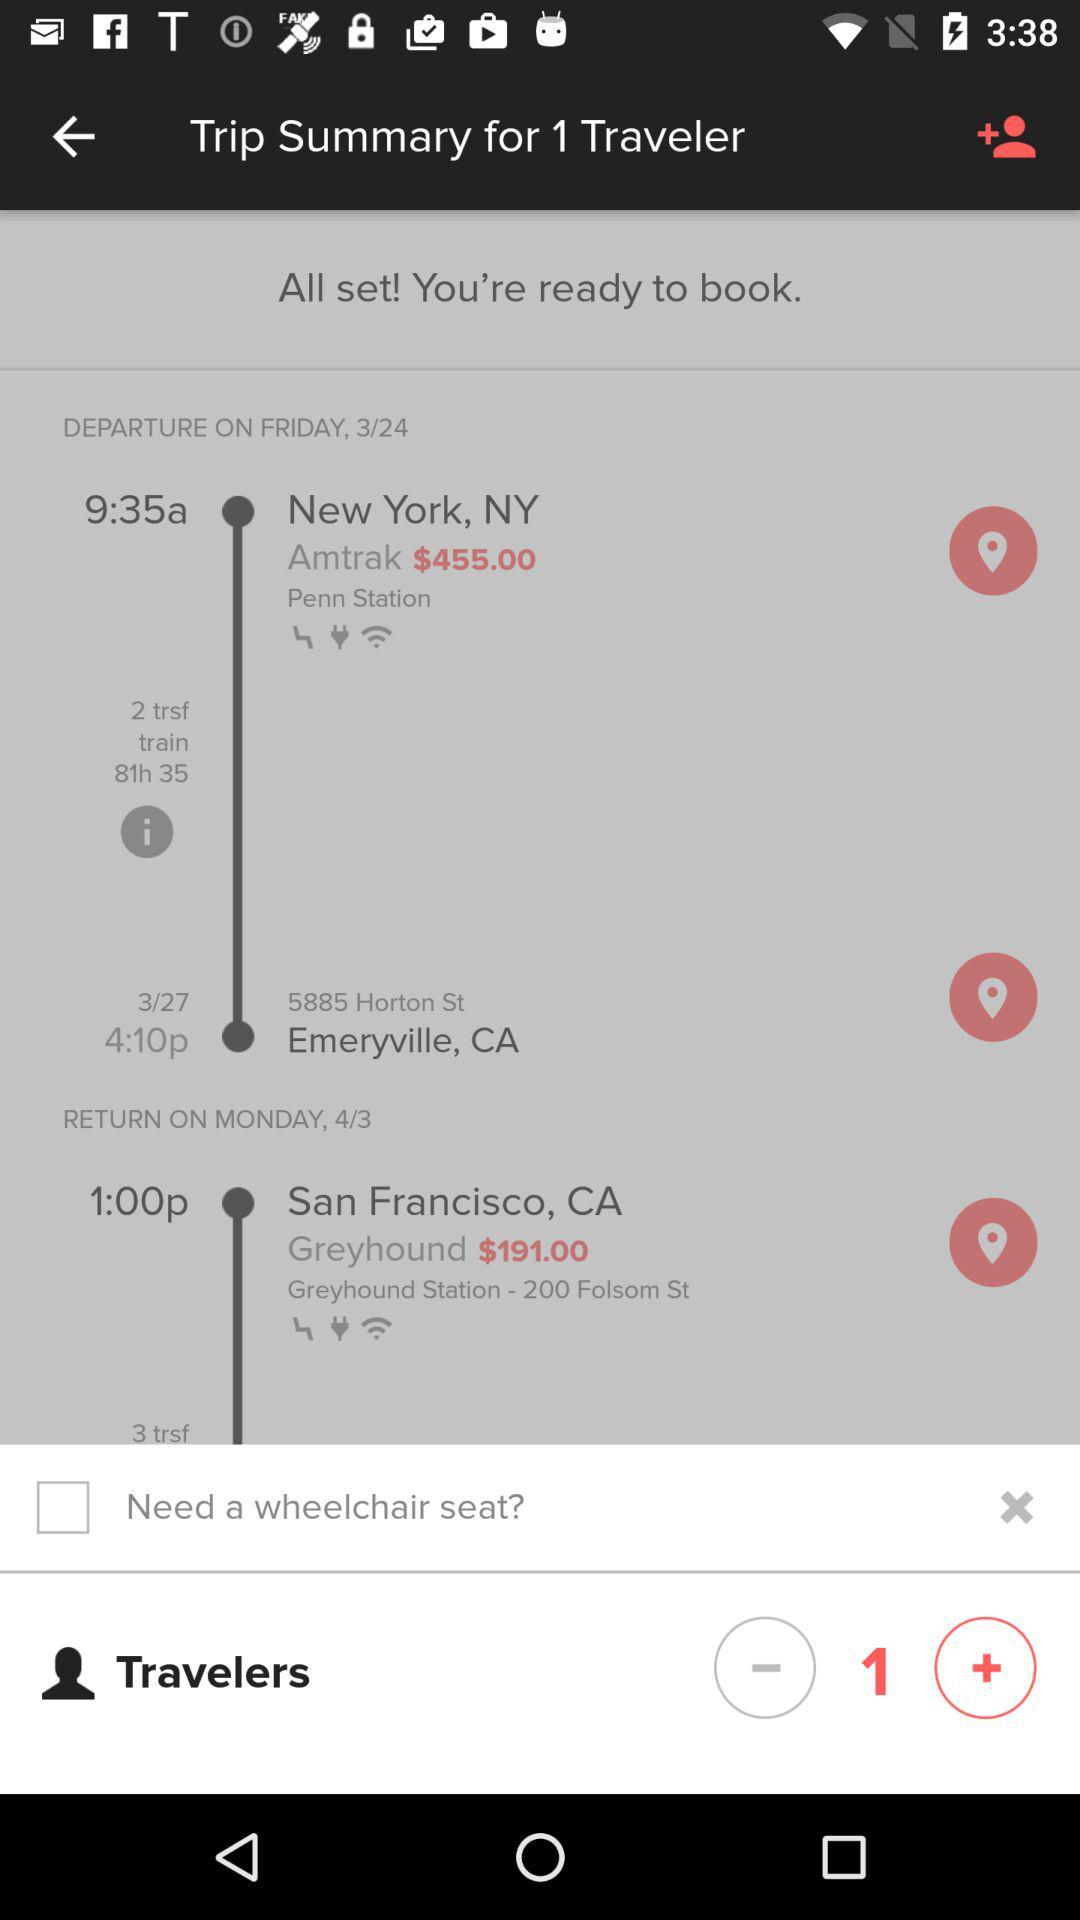What is the date of departure? The departure date is Friday, March 24. 